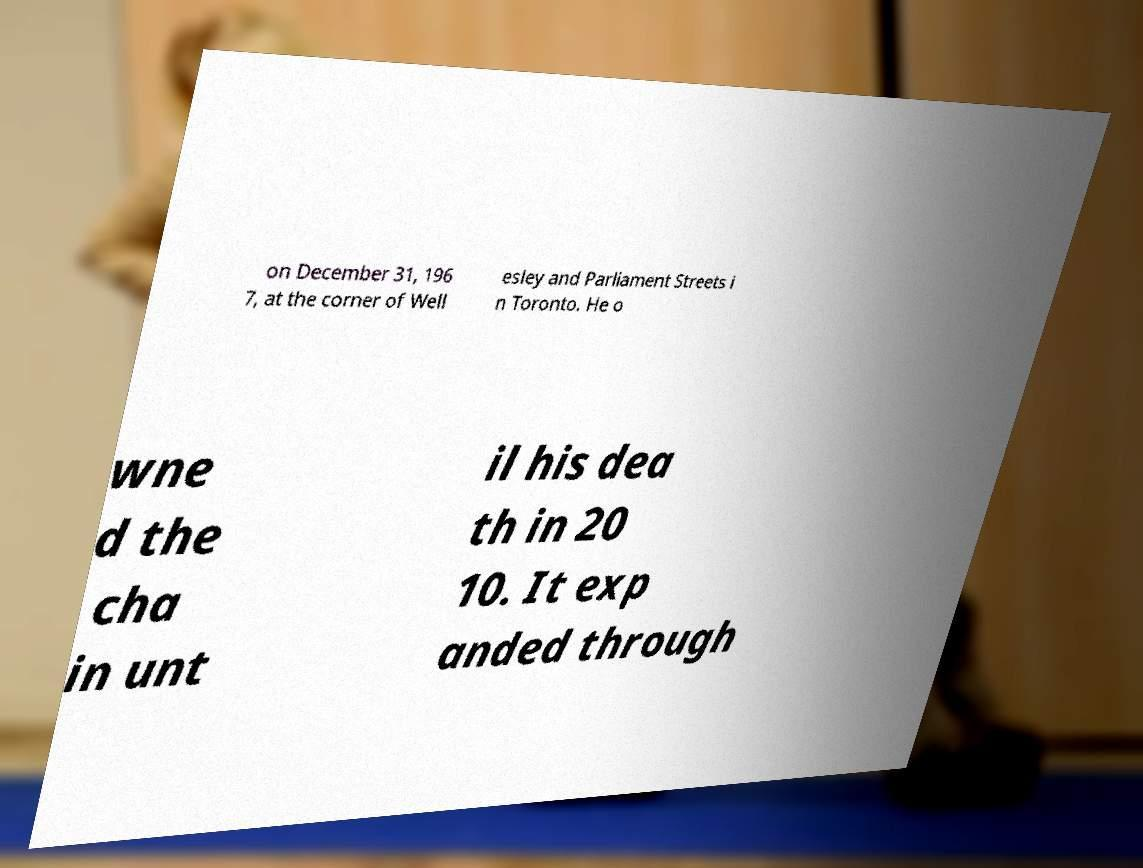Could you assist in decoding the text presented in this image and type it out clearly? on December 31, 196 7, at the corner of Well esley and Parliament Streets i n Toronto. He o wne d the cha in unt il his dea th in 20 10. It exp anded through 